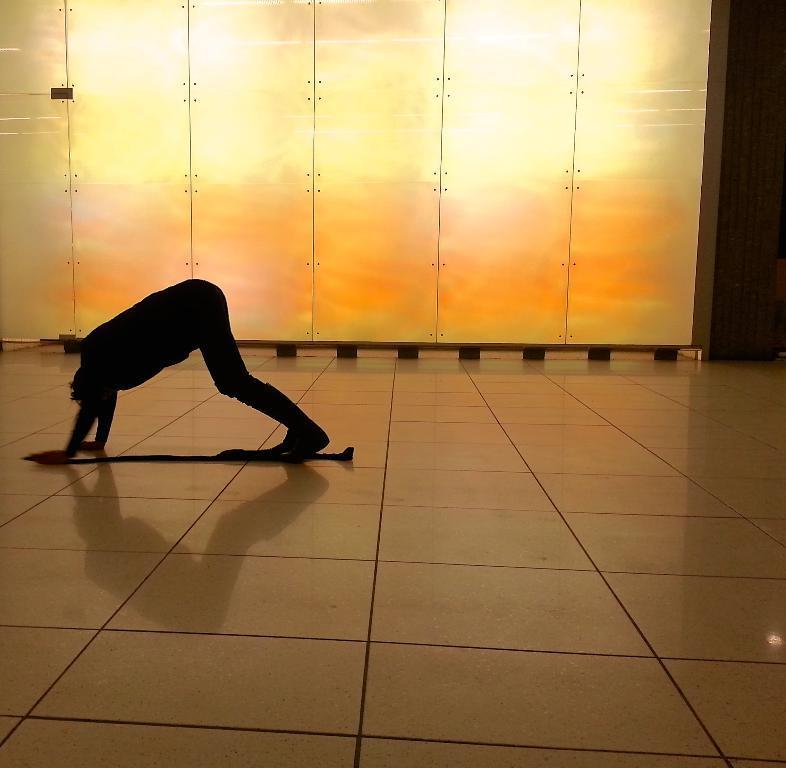Could you give a brief overview of what you see in this image? This is an inside view. On the left side there is a person on the floor. It seems like this person is doing some exercise. In the background there is a wall. 